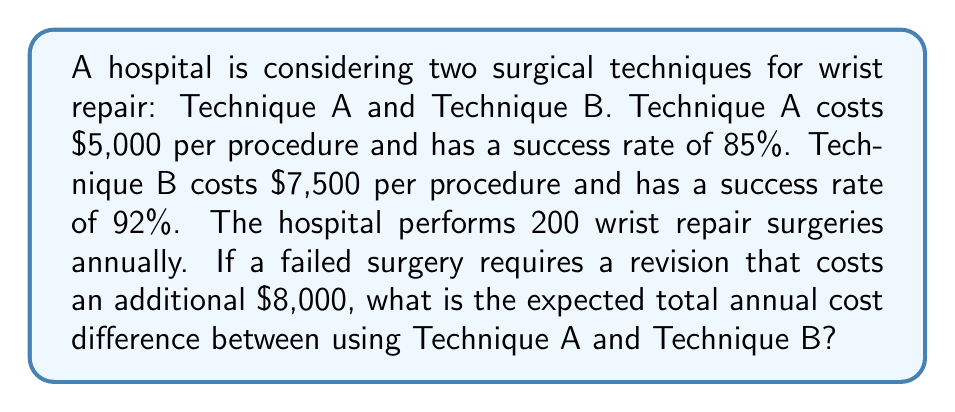Solve this math problem. Let's approach this problem step-by-step:

1. Calculate the number of successful and failed surgeries for each technique:
   Technique A: 
   Successful: $200 \times 0.85 = 170$
   Failed: $200 \times 0.15 = 30$

   Technique B:
   Successful: $200 \times 0.92 = 184$
   Failed: $200 \times 0.08 = 16$

2. Calculate the total cost for Technique A:
   Initial surgeries: $200 \times \$5,000 = \$1,000,000$
   Revisions: $30 \times \$8,000 = \$240,000$
   Total A: $\$1,000,000 + \$240,000 = \$1,240,000$

3. Calculate the total cost for Technique B:
   Initial surgeries: $200 \times \$7,500 = \$1,500,000$
   Revisions: $16 \times \$8,000 = \$128,000$
   Total B: $\$1,500,000 + \$128,000 = \$1,628,000$

4. Calculate the difference:
   $$\text{Difference} = \text{Total B} - \text{Total A}$$
   $$\text{Difference} = \$1,628,000 - \$1,240,000 = \$388,000$$

Therefore, the expected total annual cost difference between using Technique B and Technique A is $388,000, with Technique B being more expensive.
Answer: $388,000 